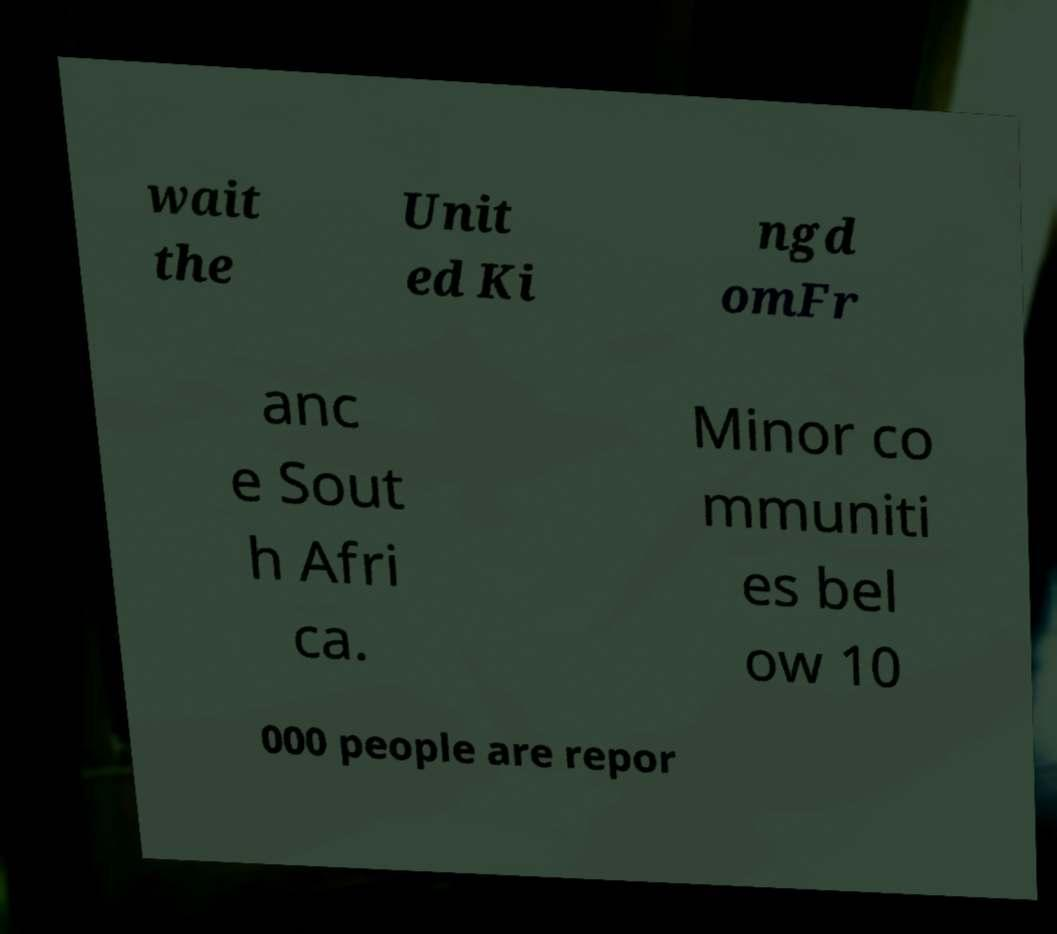Please read and relay the text visible in this image. What does it say? wait the Unit ed Ki ngd omFr anc e Sout h Afri ca. Minor co mmuniti es bel ow 10 000 people are repor 